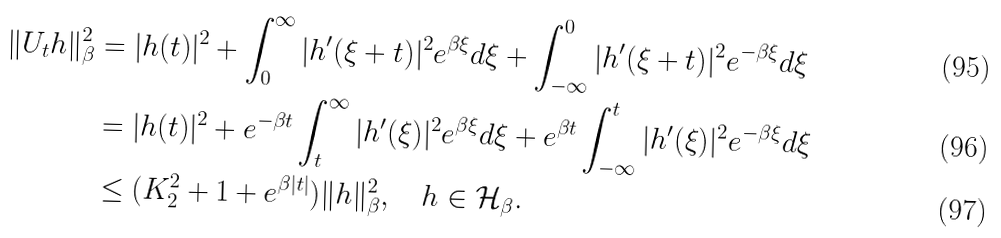<formula> <loc_0><loc_0><loc_500><loc_500>\| U _ { t } h \| _ { \beta } ^ { 2 } & = | h ( t ) | ^ { 2 } + \int _ { 0 } ^ { \infty } | h ^ { \prime } ( \xi + t ) | ^ { 2 } e ^ { \beta \xi } d \xi + \int _ { - \infty } ^ { 0 } | h ^ { \prime } ( \xi + t ) | ^ { 2 } e ^ { - \beta \xi } d \xi \\ & = | h ( t ) | ^ { 2 } + e ^ { - \beta t } \int _ { t } ^ { \infty } | h ^ { \prime } ( \xi ) | ^ { 2 } e ^ { \beta \xi } d \xi + e ^ { \beta t } \int _ { - \infty } ^ { t } | h ^ { \prime } ( \xi ) | ^ { 2 } e ^ { - \beta \xi } d \xi \\ & \leq ( K _ { 2 } ^ { 2 } + 1 + e ^ { \beta | t | } ) \| h \| _ { \beta } ^ { 2 } , \quad h \in \mathcal { H } _ { \beta } .</formula> 